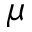<formula> <loc_0><loc_0><loc_500><loc_500>\mu</formula> 